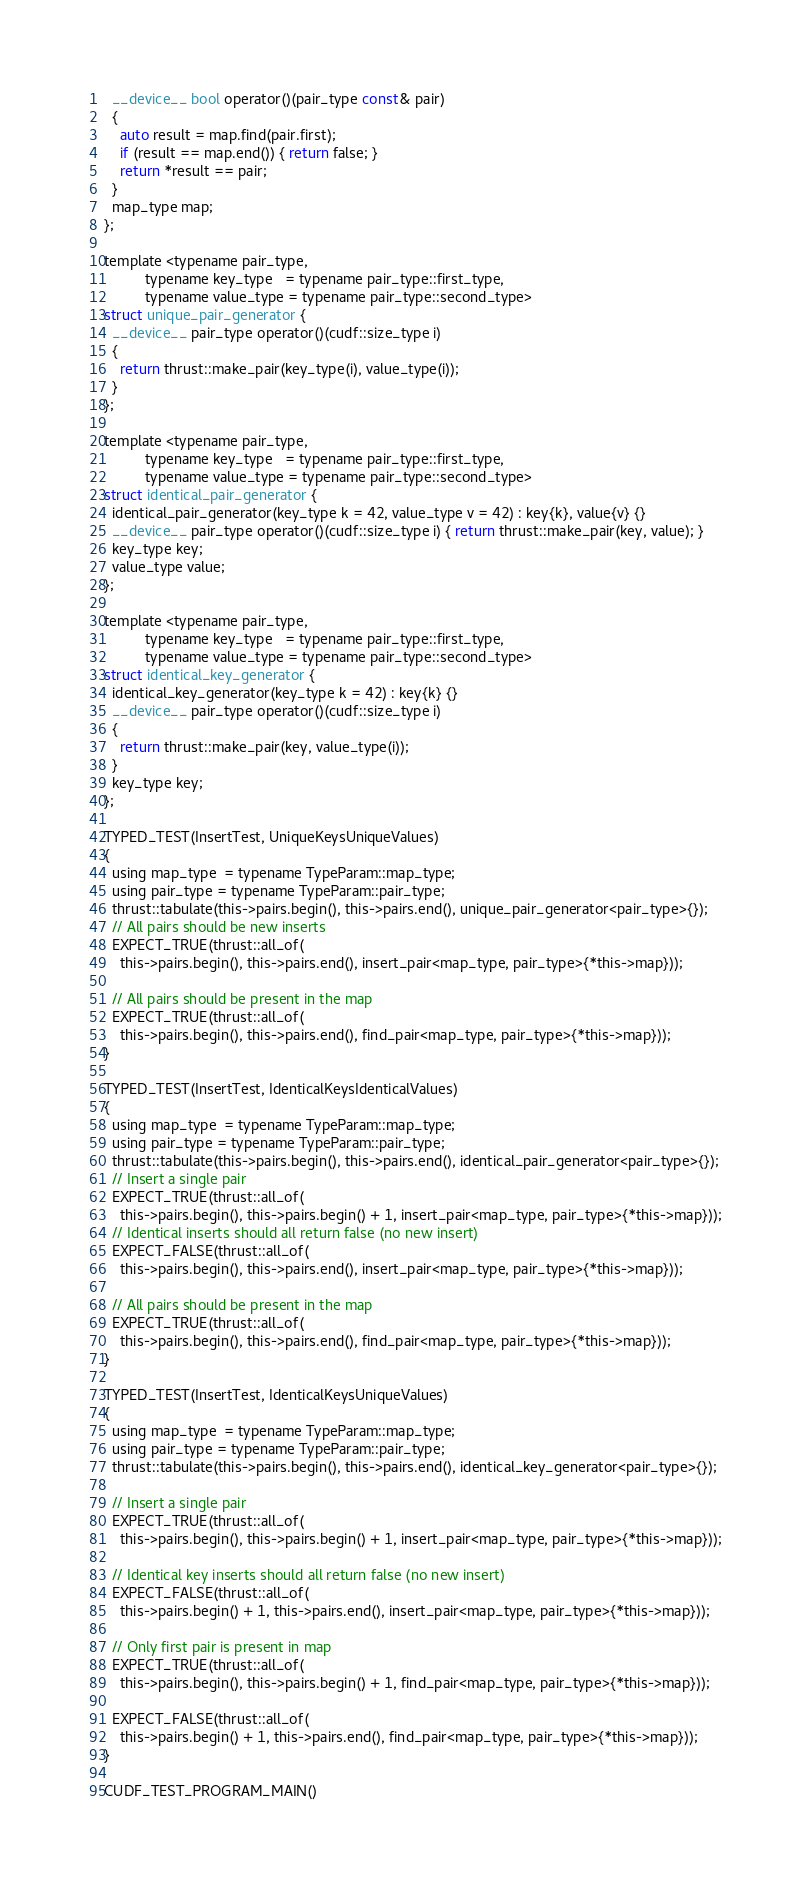Convert code to text. <code><loc_0><loc_0><loc_500><loc_500><_Cuda_>  __device__ bool operator()(pair_type const& pair)
  {
    auto result = map.find(pair.first);
    if (result == map.end()) { return false; }
    return *result == pair;
  }
  map_type map;
};

template <typename pair_type,
          typename key_type   = typename pair_type::first_type,
          typename value_type = typename pair_type::second_type>
struct unique_pair_generator {
  __device__ pair_type operator()(cudf::size_type i)
  {
    return thrust::make_pair(key_type(i), value_type(i));
  }
};

template <typename pair_type,
          typename key_type   = typename pair_type::first_type,
          typename value_type = typename pair_type::second_type>
struct identical_pair_generator {
  identical_pair_generator(key_type k = 42, value_type v = 42) : key{k}, value{v} {}
  __device__ pair_type operator()(cudf::size_type i) { return thrust::make_pair(key, value); }
  key_type key;
  value_type value;
};

template <typename pair_type,
          typename key_type   = typename pair_type::first_type,
          typename value_type = typename pair_type::second_type>
struct identical_key_generator {
  identical_key_generator(key_type k = 42) : key{k} {}
  __device__ pair_type operator()(cudf::size_type i)
  {
    return thrust::make_pair(key, value_type(i));
  }
  key_type key;
};

TYPED_TEST(InsertTest, UniqueKeysUniqueValues)
{
  using map_type  = typename TypeParam::map_type;
  using pair_type = typename TypeParam::pair_type;
  thrust::tabulate(this->pairs.begin(), this->pairs.end(), unique_pair_generator<pair_type>{});
  // All pairs should be new inserts
  EXPECT_TRUE(thrust::all_of(
    this->pairs.begin(), this->pairs.end(), insert_pair<map_type, pair_type>{*this->map}));

  // All pairs should be present in the map
  EXPECT_TRUE(thrust::all_of(
    this->pairs.begin(), this->pairs.end(), find_pair<map_type, pair_type>{*this->map}));
}

TYPED_TEST(InsertTest, IdenticalKeysIdenticalValues)
{
  using map_type  = typename TypeParam::map_type;
  using pair_type = typename TypeParam::pair_type;
  thrust::tabulate(this->pairs.begin(), this->pairs.end(), identical_pair_generator<pair_type>{});
  // Insert a single pair
  EXPECT_TRUE(thrust::all_of(
    this->pairs.begin(), this->pairs.begin() + 1, insert_pair<map_type, pair_type>{*this->map}));
  // Identical inserts should all return false (no new insert)
  EXPECT_FALSE(thrust::all_of(
    this->pairs.begin(), this->pairs.end(), insert_pair<map_type, pair_type>{*this->map}));

  // All pairs should be present in the map
  EXPECT_TRUE(thrust::all_of(
    this->pairs.begin(), this->pairs.end(), find_pair<map_type, pair_type>{*this->map}));
}

TYPED_TEST(InsertTest, IdenticalKeysUniqueValues)
{
  using map_type  = typename TypeParam::map_type;
  using pair_type = typename TypeParam::pair_type;
  thrust::tabulate(this->pairs.begin(), this->pairs.end(), identical_key_generator<pair_type>{});

  // Insert a single pair
  EXPECT_TRUE(thrust::all_of(
    this->pairs.begin(), this->pairs.begin() + 1, insert_pair<map_type, pair_type>{*this->map}));

  // Identical key inserts should all return false (no new insert)
  EXPECT_FALSE(thrust::all_of(
    this->pairs.begin() + 1, this->pairs.end(), insert_pair<map_type, pair_type>{*this->map}));

  // Only first pair is present in map
  EXPECT_TRUE(thrust::all_of(
    this->pairs.begin(), this->pairs.begin() + 1, find_pair<map_type, pair_type>{*this->map}));

  EXPECT_FALSE(thrust::all_of(
    this->pairs.begin() + 1, this->pairs.end(), find_pair<map_type, pair_type>{*this->map}));
}

CUDF_TEST_PROGRAM_MAIN()
</code> 